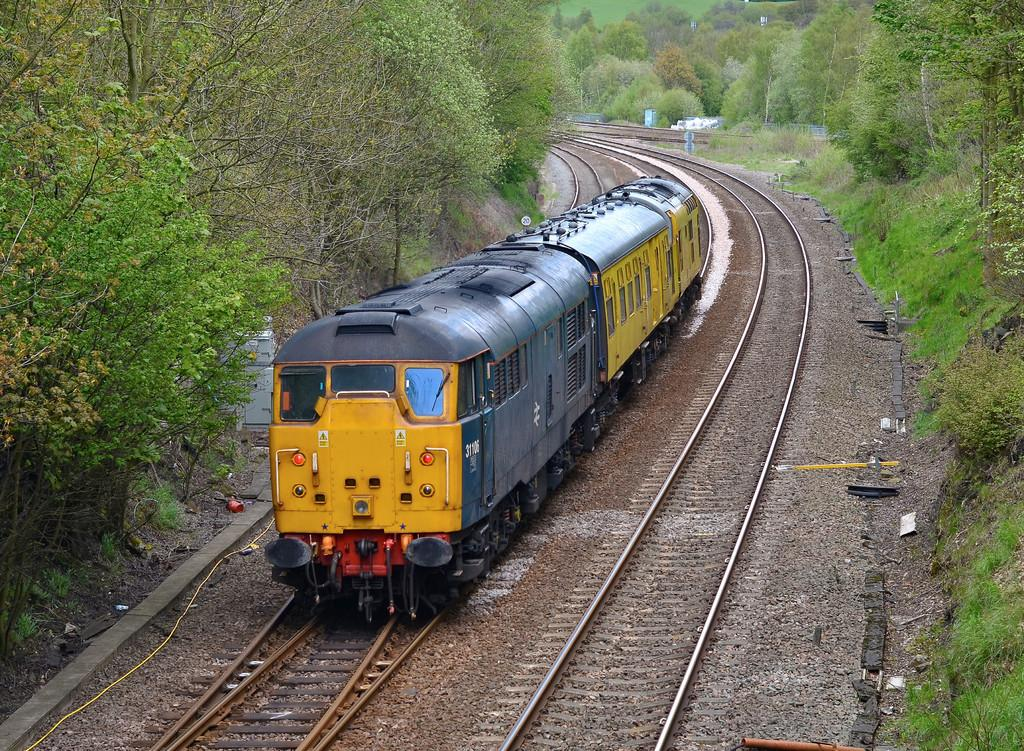What is the main subject of the image? The main subject of the image is a train. Where is the train located in the image? The train is on a track. What type of natural elements can be seen in the image? There are stones, trees, and grass visible in the image. How many grapes are on the table in the image? There is no table or grapes present in the image; it features a train on a track with natural elements in the background. 